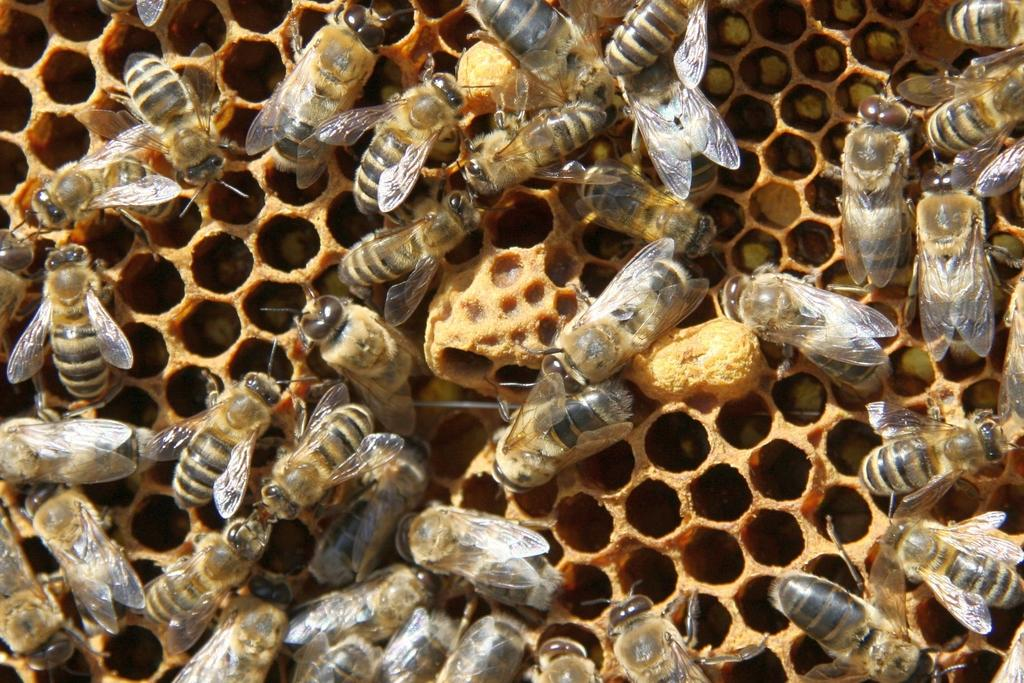What type of insects are present in the image? There are honey bees in the image. Where are the honey bees located? The honey bees are on a beehive. What type of wound can be seen on the fruit in the image? There is no fruit present in the image, and therefore no wound can be observed. 